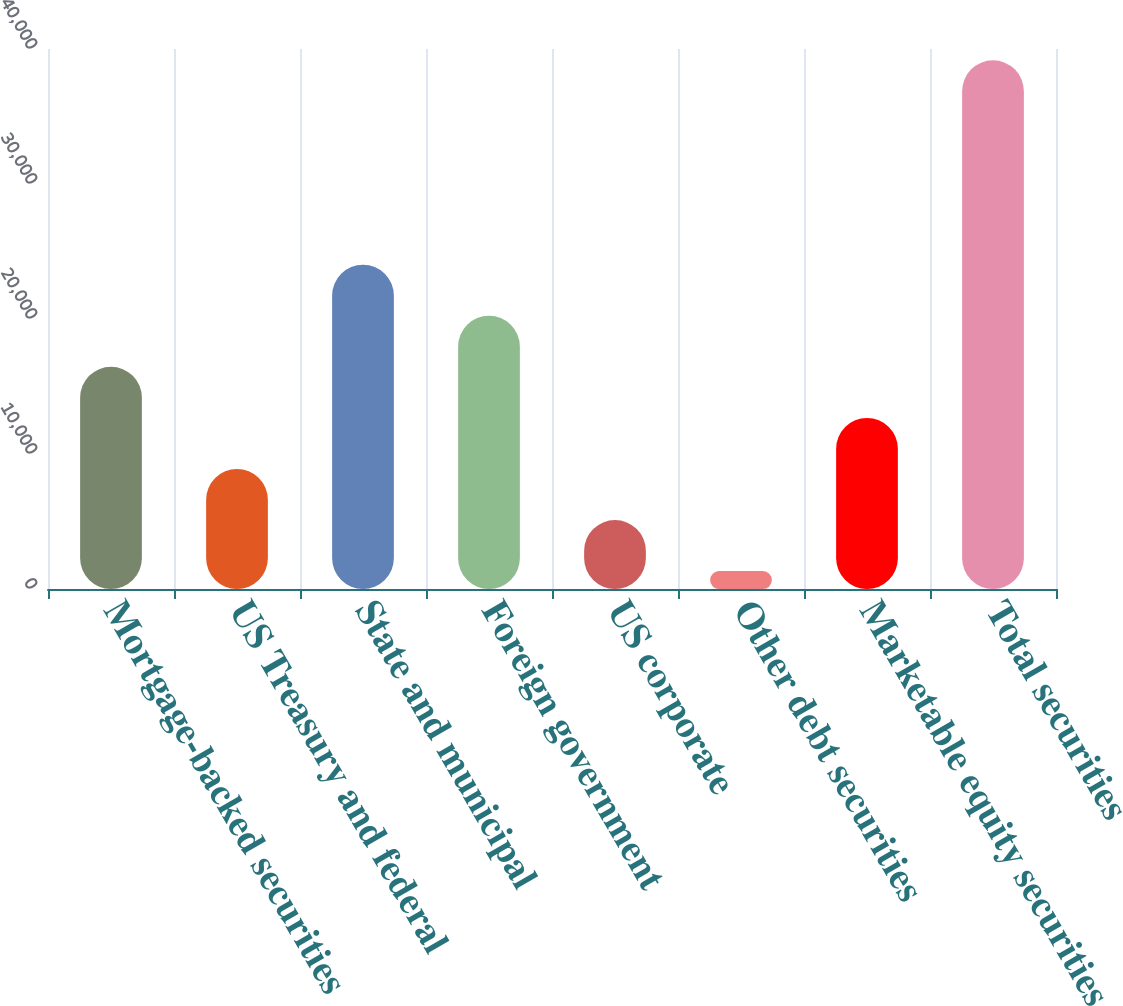Convert chart to OTSL. <chart><loc_0><loc_0><loc_500><loc_500><bar_chart><fcel>Mortgage-backed securities<fcel>US Treasury and federal<fcel>State and municipal<fcel>Foreign government<fcel>US corporate<fcel>Other debt securities<fcel>Marketable equity securities<fcel>Total securities<nl><fcel>16459.4<fcel>8892.2<fcel>24026.6<fcel>20243<fcel>5108.6<fcel>1325<fcel>12675.8<fcel>39161<nl></chart> 